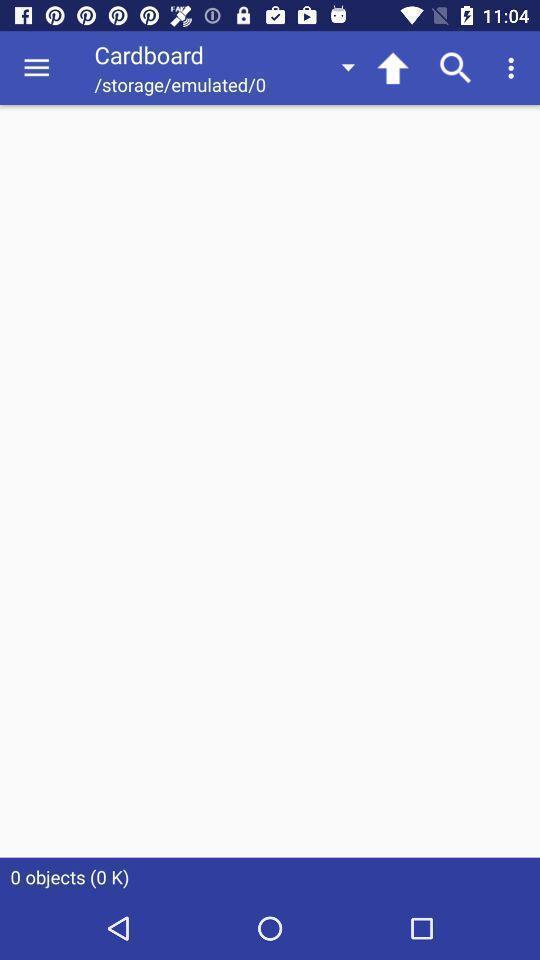What is the overall content of this screenshot? Screen shows cardboard option. 